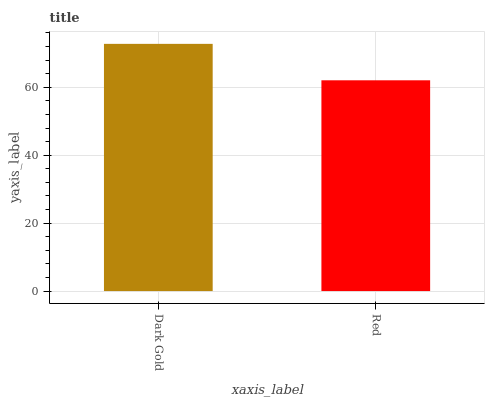Is Red the minimum?
Answer yes or no. Yes. Is Dark Gold the maximum?
Answer yes or no. Yes. Is Red the maximum?
Answer yes or no. No. Is Dark Gold greater than Red?
Answer yes or no. Yes. Is Red less than Dark Gold?
Answer yes or no. Yes. Is Red greater than Dark Gold?
Answer yes or no. No. Is Dark Gold less than Red?
Answer yes or no. No. Is Dark Gold the high median?
Answer yes or no. Yes. Is Red the low median?
Answer yes or no. Yes. Is Red the high median?
Answer yes or no. No. Is Dark Gold the low median?
Answer yes or no. No. 